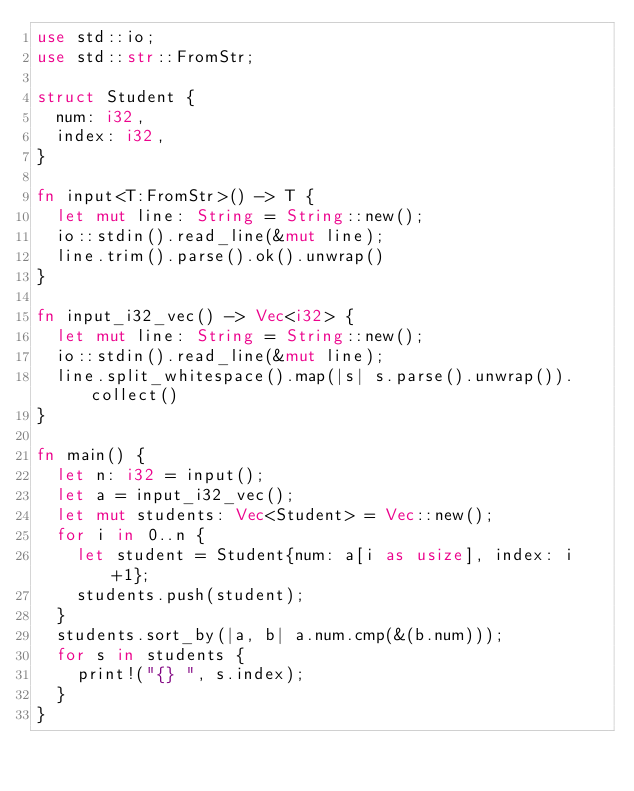Convert code to text. <code><loc_0><loc_0><loc_500><loc_500><_Rust_>use std::io;
use std::str::FromStr;

struct Student {
  num: i32,
  index: i32,
}

fn input<T:FromStr>() -> T {
  let mut line: String = String::new();
  io::stdin().read_line(&mut line);
  line.trim().parse().ok().unwrap()
}

fn input_i32_vec() -> Vec<i32> {
  let mut line: String = String::new();
  io::stdin().read_line(&mut line);
  line.split_whitespace().map(|s| s.parse().unwrap()).collect()
}

fn main() {
  let n: i32 = input();
  let a = input_i32_vec();
  let mut students: Vec<Student> = Vec::new();
  for i in 0..n {
    let student = Student{num: a[i as usize], index: i+1};
    students.push(student);
  }
  students.sort_by(|a, b| a.num.cmp(&(b.num)));
  for s in students {
    print!("{} ", s.index);
  }
}
</code> 